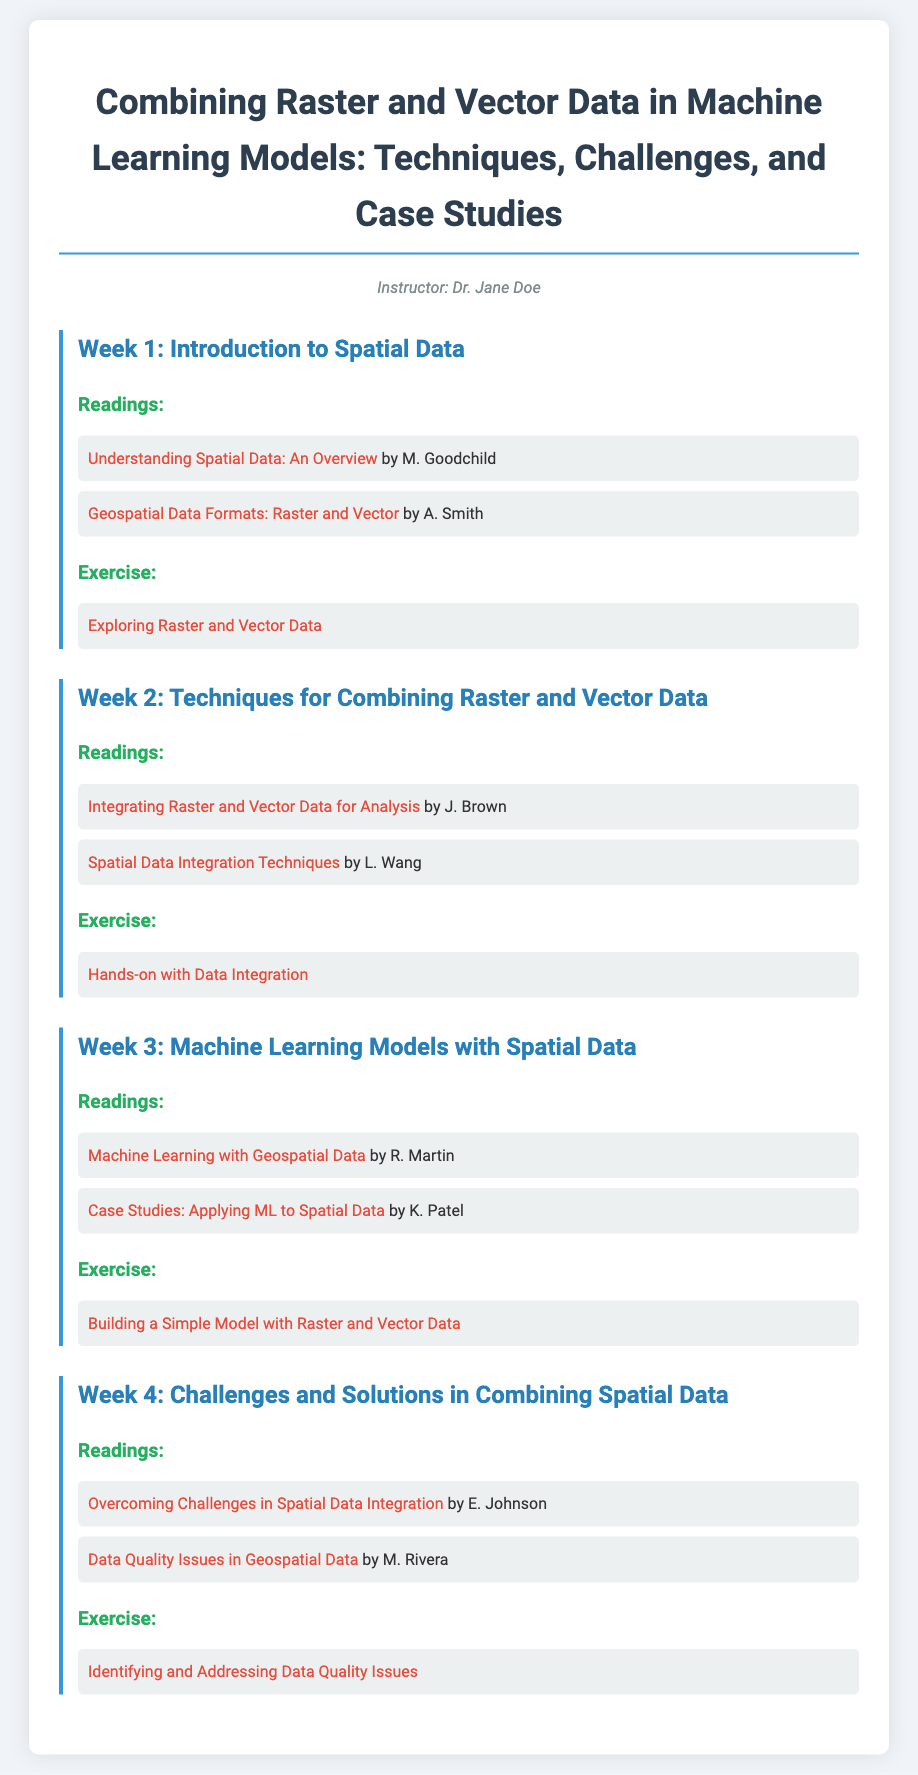What is the title of the syllabus? The title is provided at the top of the document and reflects the main focus of the course.
Answer: Combining Raster and Vector Data in Machine Learning Models: Techniques, Challenges, and Case Studies Who is the instructor of the course? The instructor's name is mentioned under the title, specifying who will be teaching the syllabus content.
Answer: Dr. Jane Doe Which week focuses on the introduction to spatial data? The weeks are numbered, and each covers specific topics; Week 1 is listed for the introduction.
Answer: Week 1 What is the focus of Week 3? The title of Week 3 highlights the specific theme or subject matter discussed during that week.
Answer: Machine Learning Models with Spatial Data Name one reading for Week 2. Each week lists specific readings; one can be extracted from the Week 2 section.
Answer: Integrating Raster and Vector Data for Analysis What exercise is suggested for Week 4? Each week concludes with an exercise title; this question focuses on the exercise from Week 4.
Answer: Identifying and Addressing Data Quality Issues Which author wrote about data quality issues in geospatial data? The document mentions specific authors for readings, and this identifies the author related to data quality issues.
Answer: M. Rivera How many weeks are covered in the syllabus? The document lists out the weeks covered, indicating the total number of weeks.
Answer: 4 